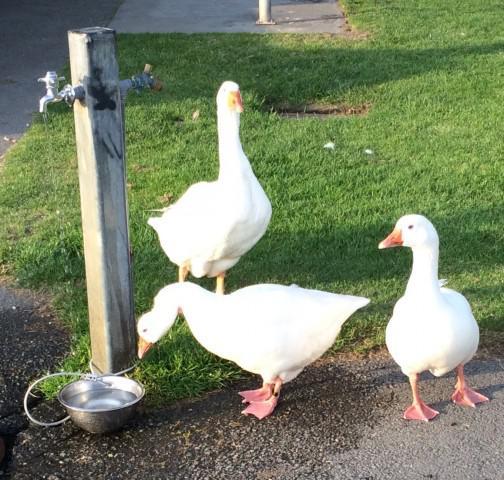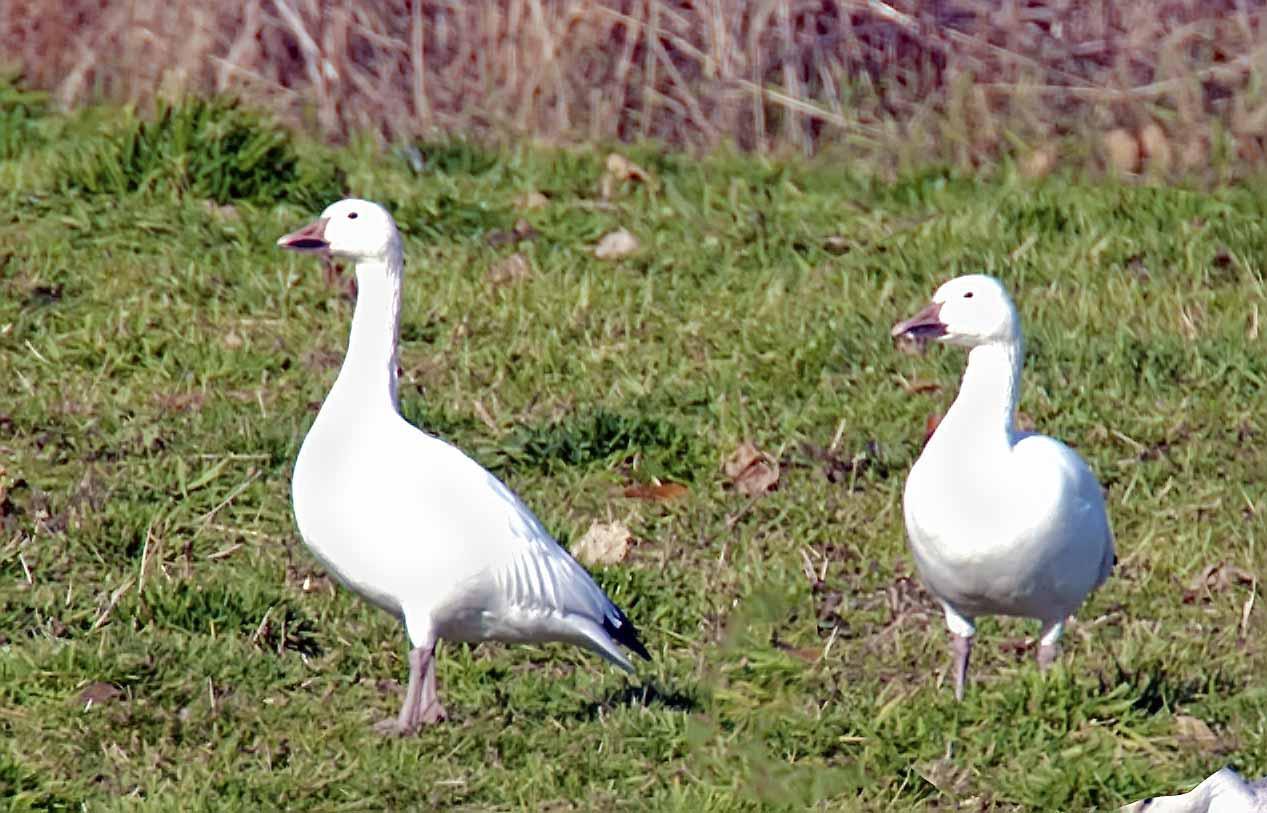The first image is the image on the left, the second image is the image on the right. For the images shown, is this caption "The left image contains exactly two white ducks." true? Answer yes or no. No. The first image is the image on the left, the second image is the image on the right. Examine the images to the left and right. Is the description "All ducks shown are white, and no image includes fuzzy ducklings." accurate? Answer yes or no. Yes. 